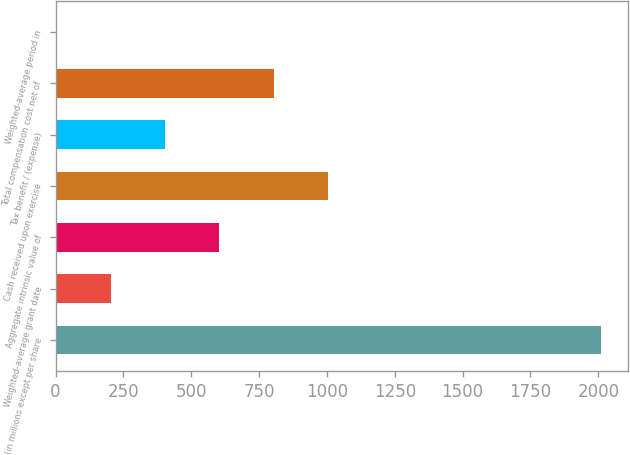<chart> <loc_0><loc_0><loc_500><loc_500><bar_chart><fcel>(in millions except per share<fcel>Weighted-average grant date<fcel>Aggregate intrinsic value of<fcel>Cash received upon exercise<fcel>Tax benefit / (expense)<fcel>Total compensation cost net of<fcel>Weighted-average period in<nl><fcel>2008<fcel>202.51<fcel>603.73<fcel>1004.95<fcel>403.12<fcel>804.34<fcel>1.9<nl></chart> 